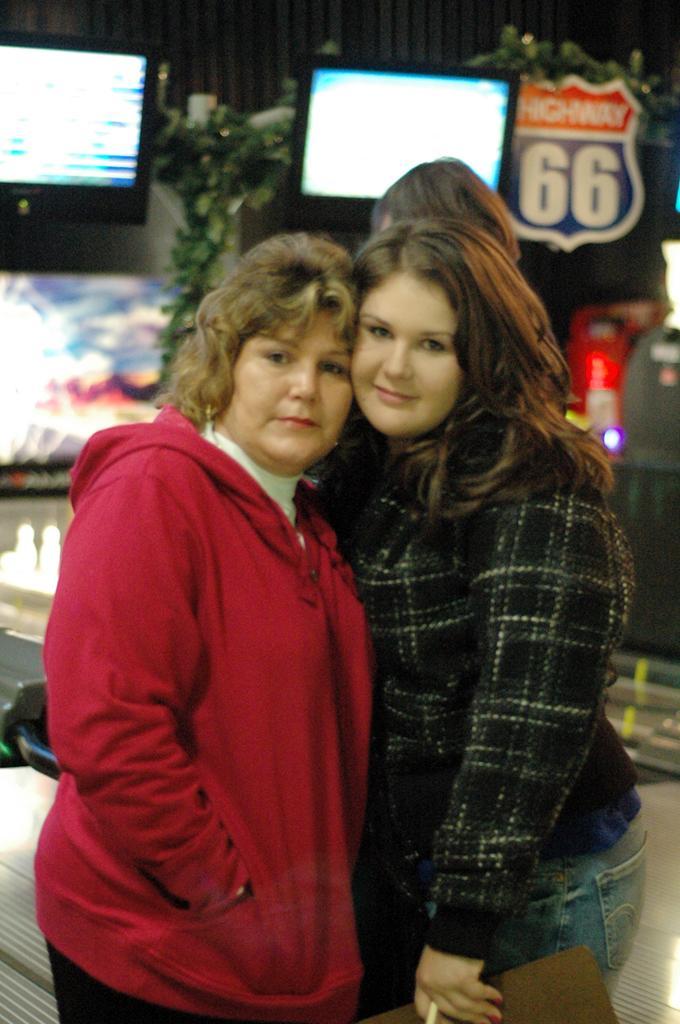Please provide a concise description of this image. In the image we can see there are two women standing, they are wearing clothes, the right side woman is holding an object in her hand. Behind them there is another person, this is a screen, plant and other objects. 